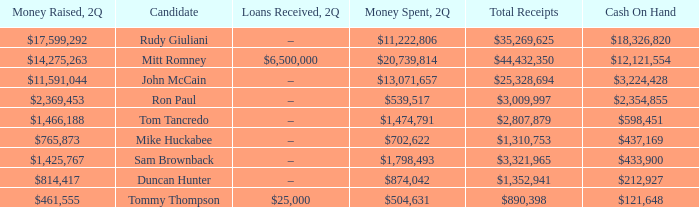Name the loans received for 2Q having total receipts of $25,328,694 –. 